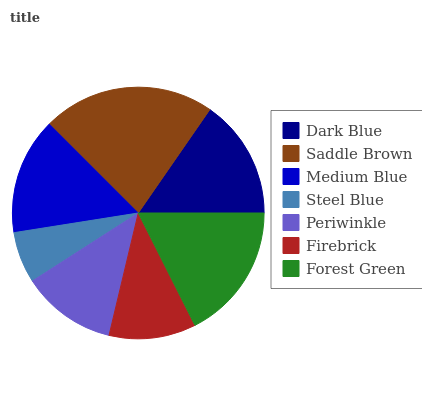Is Steel Blue the minimum?
Answer yes or no. Yes. Is Saddle Brown the maximum?
Answer yes or no. Yes. Is Medium Blue the minimum?
Answer yes or no. No. Is Medium Blue the maximum?
Answer yes or no. No. Is Saddle Brown greater than Medium Blue?
Answer yes or no. Yes. Is Medium Blue less than Saddle Brown?
Answer yes or no. Yes. Is Medium Blue greater than Saddle Brown?
Answer yes or no. No. Is Saddle Brown less than Medium Blue?
Answer yes or no. No. Is Medium Blue the high median?
Answer yes or no. Yes. Is Medium Blue the low median?
Answer yes or no. Yes. Is Periwinkle the high median?
Answer yes or no. No. Is Saddle Brown the low median?
Answer yes or no. No. 